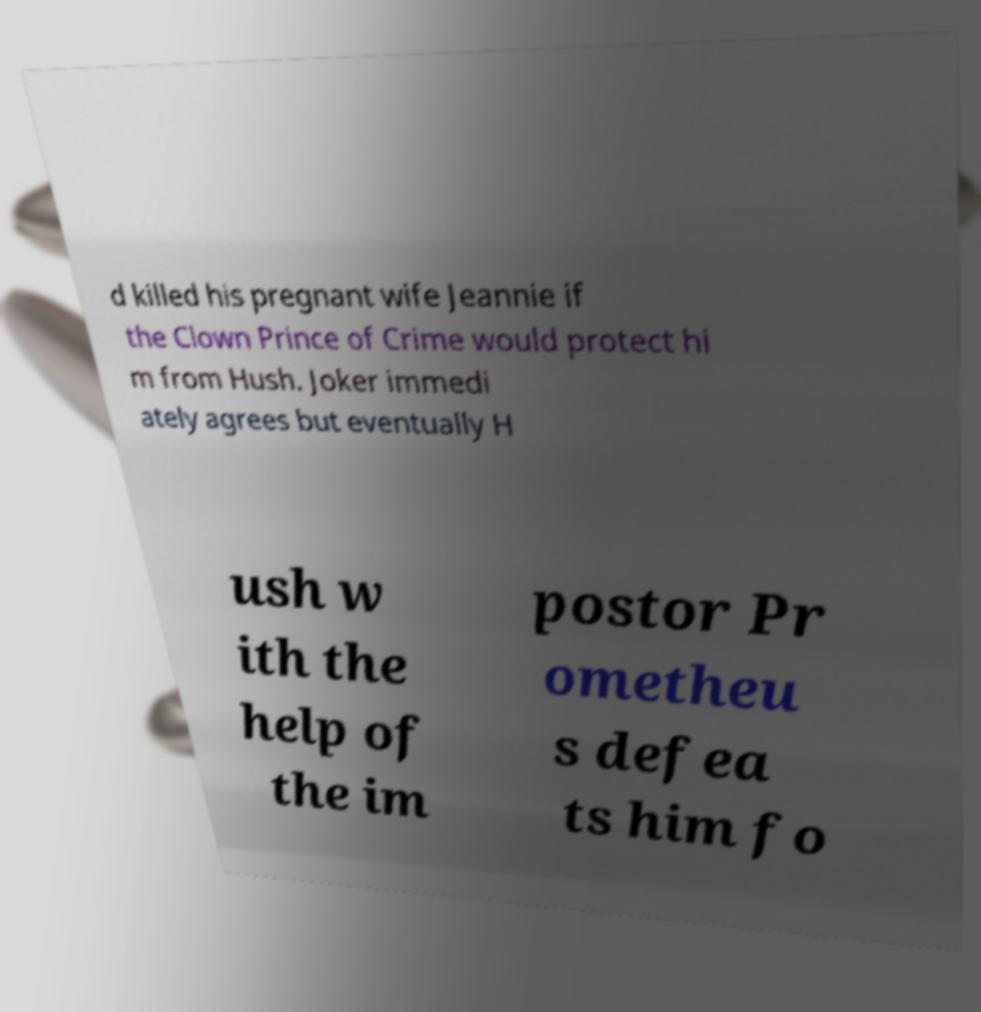Can you accurately transcribe the text from the provided image for me? d killed his pregnant wife Jeannie if the Clown Prince of Crime would protect hi m from Hush. Joker immedi ately agrees but eventually H ush w ith the help of the im postor Pr ometheu s defea ts him fo 